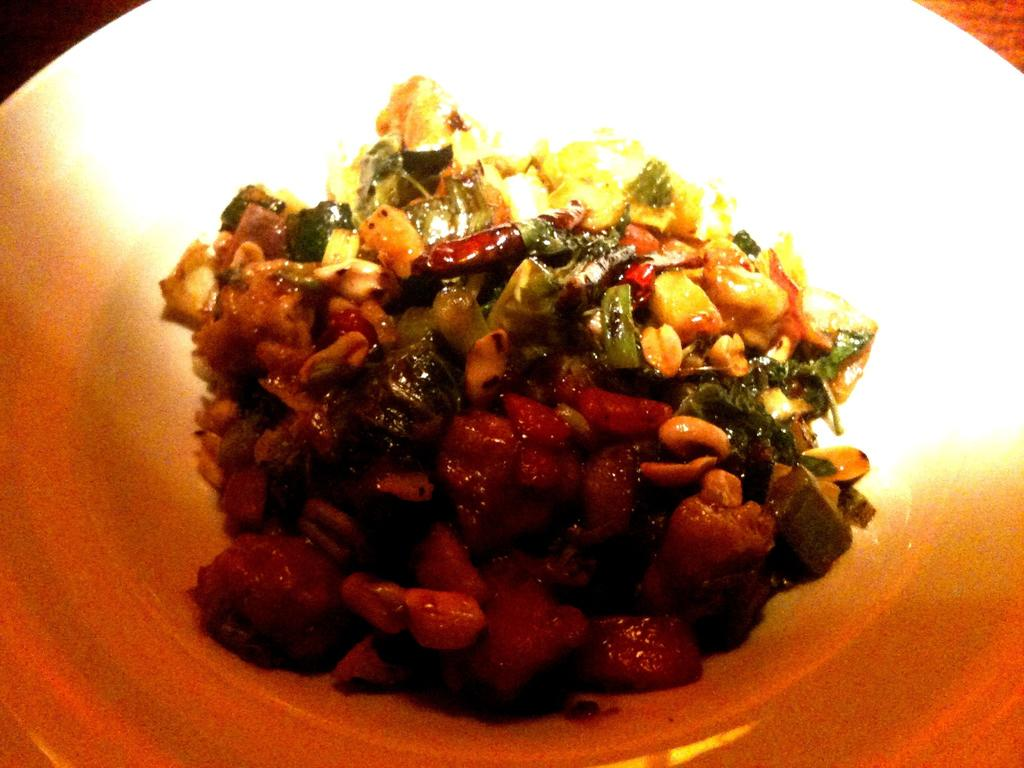What is the main subject of the image? There is a food item on a plate in the image. What type of cloud can be seen in the image? There is no cloud present in the image; it only features a food item on a plate. What type of wine is being served with the food in the image? There is no wine present in the image; it only features a food item on a plate. 